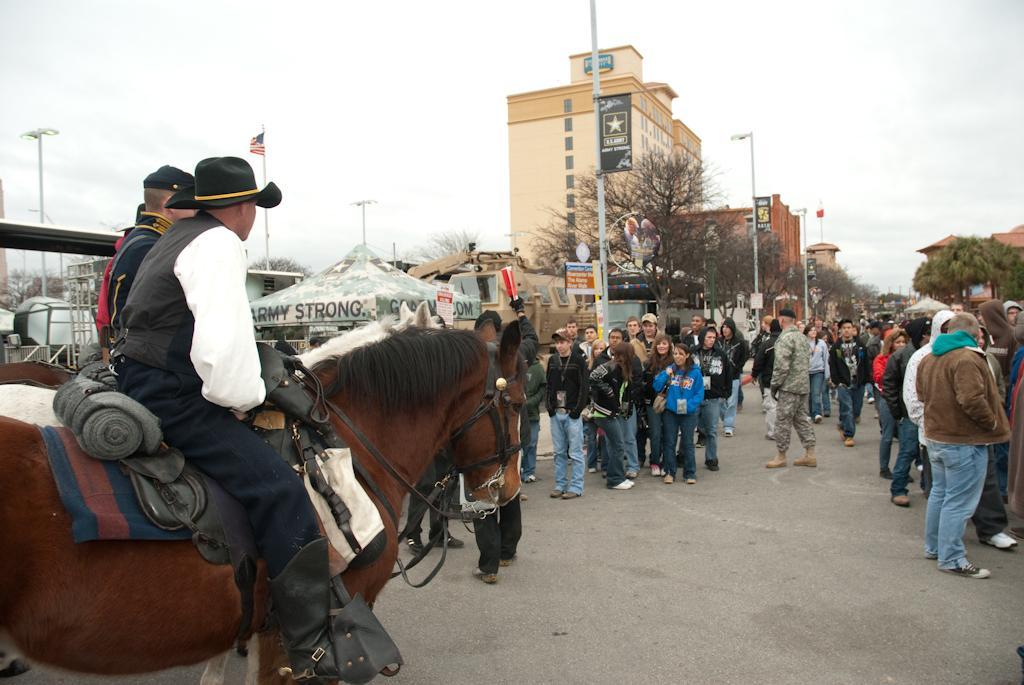Can you describe this image briefly? On the left side of the image there are men sitting on the horses. In front of them on the road there are many people standing. Behind them there are poles with sign boards and street lights. And also there are trees, buildings, tents and some other objects. At the top of the image there is sky. 